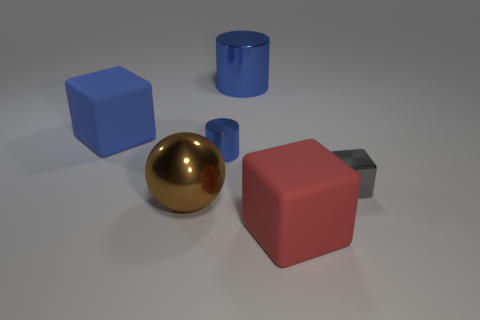Add 3 gray metal things. How many objects exist? 9 Subtract all small cubes. How many cubes are left? 2 Add 6 blue objects. How many blue objects are left? 9 Add 4 brown balls. How many brown balls exist? 5 Subtract all red blocks. How many blocks are left? 2 Subtract 0 green blocks. How many objects are left? 6 Subtract all balls. How many objects are left? 5 Subtract 2 blocks. How many blocks are left? 1 Subtract all yellow balls. Subtract all green cylinders. How many balls are left? 1 Subtract all tiny gray cubes. Subtract all metallic balls. How many objects are left? 4 